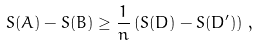Convert formula to latex. <formula><loc_0><loc_0><loc_500><loc_500>S ( A ) - S ( B ) \geq \frac { 1 } { n } \left ( S ( D ) - S ( D ^ { \prime } ) \right ) \, ,</formula> 